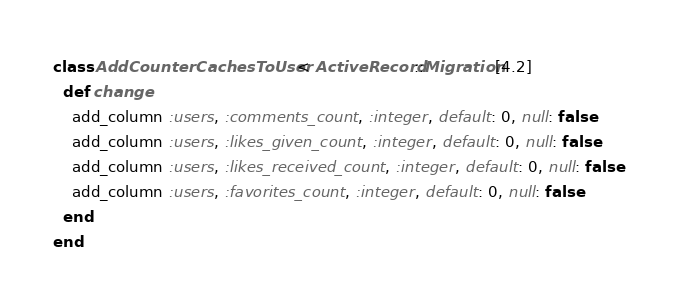Convert code to text. <code><loc_0><loc_0><loc_500><loc_500><_Ruby_>class AddCounterCachesToUser < ActiveRecord::Migration[4.2]
  def change
    add_column :users, :comments_count, :integer, default: 0, null: false
    add_column :users, :likes_given_count, :integer, default: 0, null: false
    add_column :users, :likes_received_count, :integer, default: 0, null: false
    add_column :users, :favorites_count, :integer, default: 0, null: false
  end
end
</code> 